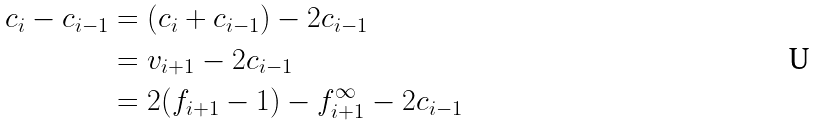Convert formula to latex. <formula><loc_0><loc_0><loc_500><loc_500>c _ { i } - c _ { i - 1 } & = ( c _ { i } + c _ { i - 1 } ) - 2 c _ { i - 1 } \\ & = v _ { i + 1 } - 2 c _ { i - 1 } \\ & = 2 ( f _ { i + 1 } - 1 ) - f _ { i + 1 } ^ { \infty } - 2 c _ { i - 1 }</formula> 